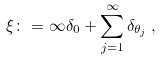<formula> <loc_0><loc_0><loc_500><loc_500>\xi \colon = \infty \delta _ { 0 } + \sum _ { j = 1 } ^ { \infty } \delta _ { \theta _ { j } } \, ,</formula> 